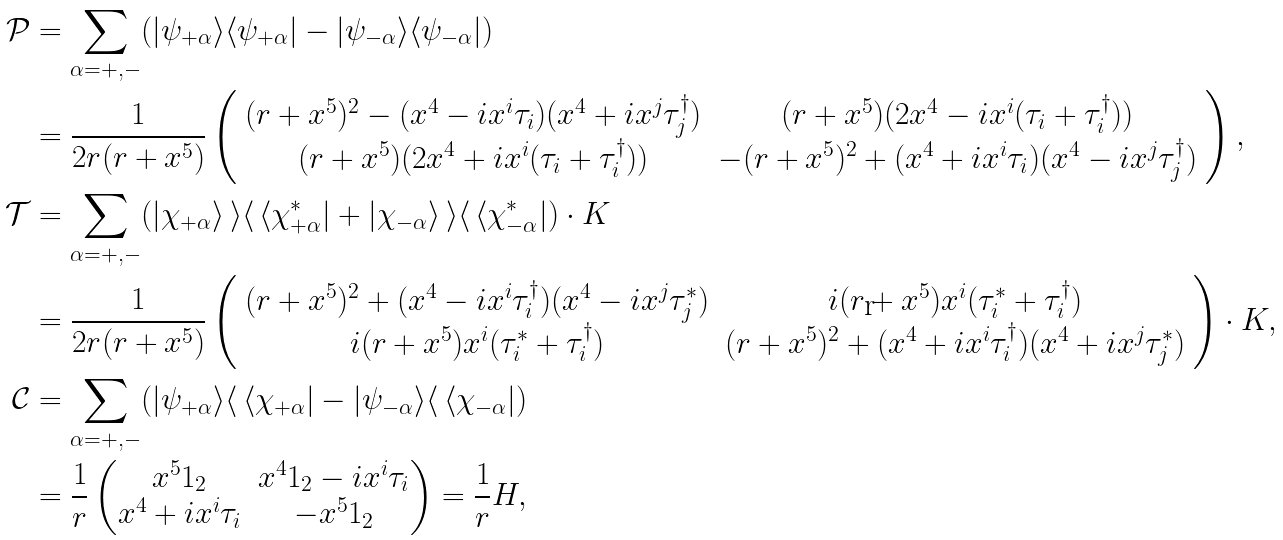Convert formula to latex. <formula><loc_0><loc_0><loc_500><loc_500>\mathcal { P } & = \sum _ { \alpha = + , - } ( | \psi _ { + \alpha } \rangle \langle \psi _ { + \alpha } | - | \psi _ { - \alpha } \rangle \langle \psi _ { - \alpha } | ) \\ & = \frac { 1 } { 2 r ( r + x ^ { 5 } ) } \left ( \begin{array} { c c } ( r + x ^ { 5 } ) ^ { 2 } - ( x ^ { 4 } - i x ^ { i } \tau _ { i } ) ( x ^ { 4 } + i x ^ { j } \tau _ { j } ^ { \dagger } ) & ( r + x ^ { 5 } ) ( 2 x ^ { 4 } - i x ^ { i } ( \tau _ { i } + \tau _ { i } ^ { \dagger } ) ) \\ ( r + x ^ { 5 } ) ( 2 x ^ { 4 } + i x ^ { i } ( \tau _ { i } + \tau _ { i } ^ { \dagger } ) ) & - ( r + x ^ { 5 } ) ^ { 2 } + ( x ^ { 4 } + i x ^ { i } \tau _ { i } ) ( x ^ { 4 } - i x ^ { j } \tau _ { j } ^ { \dagger } ) \end{array} \right ) , \\ \mathcal { T } & = \sum _ { \alpha = + , - } ( | \chi _ { + \alpha } \rangle \, \rangle \langle \, \langle \chi _ { + \alpha } ^ { * } | + | \chi _ { - \alpha } \rangle \, \rangle \langle \, \langle \chi _ { - \alpha } ^ { * } | ) \cdot K \\ & = \frac { 1 } { 2 r ( r + x ^ { 5 } ) } \left ( \begin{array} { c c } ( r + x ^ { 5 } ) ^ { 2 } + ( x ^ { 4 } - i x ^ { i } \tau _ { i } ^ { \dagger } ) ( x ^ { 4 } - i x ^ { j } \tau _ { j } ^ { * } ) & i ( r + x ^ { 5 } ) x ^ { i } ( \tau _ { i } ^ { * } + \tau _ { i } ^ { \dagger } ) \\ i ( r + x ^ { 5 } ) x ^ { i } ( \tau _ { i } ^ { * } + \tau _ { i } ^ { \dagger } ) & ( r + x ^ { 5 } ) ^ { 2 } + ( x ^ { 4 } + i x ^ { i } \tau _ { i } ^ { \dagger } ) ( x ^ { 4 } + i x ^ { j } \tau _ { j } ^ { * } ) \end{array} \right ) \cdot K , \\ \mathcal { C } & = \sum _ { \alpha = + , - } ( | \psi _ { + \alpha } \rangle \langle \, \langle \chi _ { + \alpha } | - | \psi _ { - \alpha } \rangle \langle \, \langle \chi _ { - \alpha } | ) \\ & = \frac { 1 } { r } \begin{pmatrix} x ^ { 5 } 1 _ { 2 } & x ^ { 4 } 1 _ { 2 } - i x ^ { i } \tau _ { i } \\ x ^ { 4 } + i x ^ { i } \tau _ { i } & - x ^ { 5 } 1 _ { 2 } \end{pmatrix} = \frac { 1 } { r } H ,</formula> 